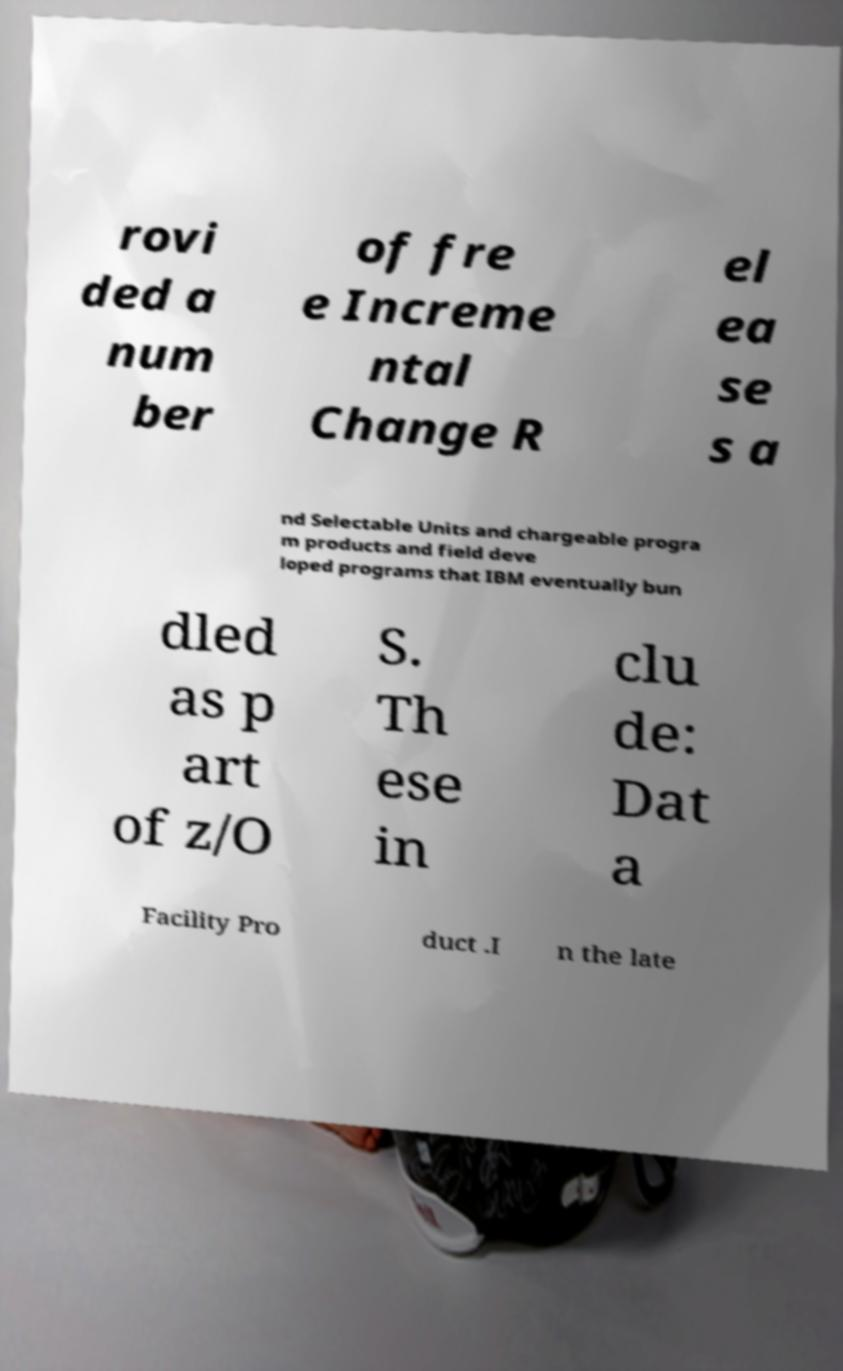Can you accurately transcribe the text from the provided image for me? rovi ded a num ber of fre e Increme ntal Change R el ea se s a nd Selectable Units and chargeable progra m products and field deve loped programs that IBM eventually bun dled as p art of z/O S. Th ese in clu de: Dat a Facility Pro duct .I n the late 